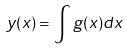Convert formula to latex. <formula><loc_0><loc_0><loc_500><loc_500>y ( x ) = \int g ( x ) d x</formula> 